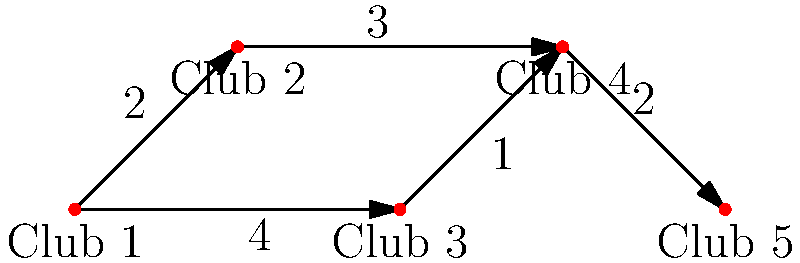A rising comedian is planning their tour through various comedy clubs. The graph represents the possible routes between clubs, with edges indicating direct connections and weights representing travel time in hours. What is the shortest time (in hours) for the comedian to travel from Club 1 to Club 5, hitting as many clubs as possible along the way? To find the shortest path from Club 1 to Club 5 while visiting as many clubs as possible, we'll use Dijkstra's algorithm:

1. Initialize:
   - Distance to Club 1: 0
   - Distance to all other clubs: ∞

2. Visit Club 1:
   - Update Club 2: min(∞, 0 + 2) = 2
   - Update Club 3: min(∞, 0 + 4) = 4

3. Visit Club 2 (closest unvisited):
   - Update Club 4: min(∞, 2 + 3) = 5

4. Visit Club 3:
   - Update Club 4: min(5, 4 + 1) = 5 (no change)

5. Visit Club 4:
   - Update Club 5: min(∞, 5 + 2) = 7

6. Visit Club 5 (destination reached)

The shortest path is: Club 1 → Club 2 → Club 4 → Club 5
Total time: 2 + 3 + 2 = 7 hours

This path allows the comedian to visit 4 out of 5 clubs, maximizing exposure while minimizing travel time.
Answer: 7 hours 